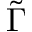<formula> <loc_0><loc_0><loc_500><loc_500>\tilde { \Gamma }</formula> 